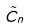Convert formula to latex. <formula><loc_0><loc_0><loc_500><loc_500>\tilde { C } _ { n }</formula> 